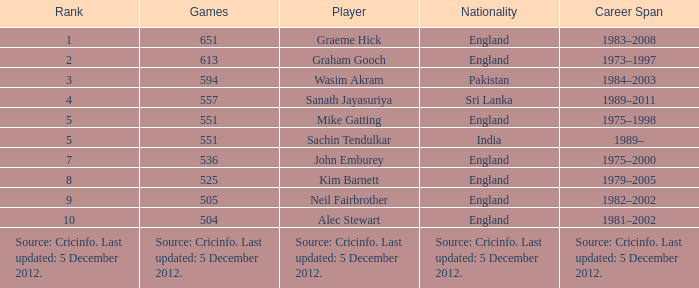What is the nationality of the player who played 505 games? England. 